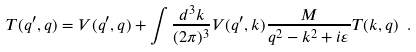Convert formula to latex. <formula><loc_0><loc_0><loc_500><loc_500>T ( { q } ^ { \prime } , { q } ) = V ( { q } ^ { \prime } , { q } ) + \int { \frac { d ^ { 3 } k } { ( 2 \pi ) ^ { 3 } } } V ( { q } ^ { \prime } , { k } ) { \frac { M } { { q } ^ { 2 } - { k } ^ { 2 } + i \varepsilon } } T ( { k } , { q } ) \ .</formula> 